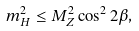<formula> <loc_0><loc_0><loc_500><loc_500>m _ { H } ^ { 2 } \leq M _ { Z } ^ { 2 } \cos ^ { 2 } 2 \beta ,</formula> 